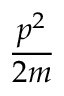<formula> <loc_0><loc_0><loc_500><loc_500>\frac { p ^ { 2 } } { 2 m }</formula> 